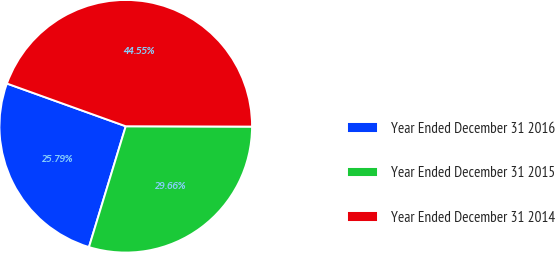Convert chart to OTSL. <chart><loc_0><loc_0><loc_500><loc_500><pie_chart><fcel>Year Ended December 31 2016<fcel>Year Ended December 31 2015<fcel>Year Ended December 31 2014<nl><fcel>25.79%<fcel>29.66%<fcel>44.55%<nl></chart> 